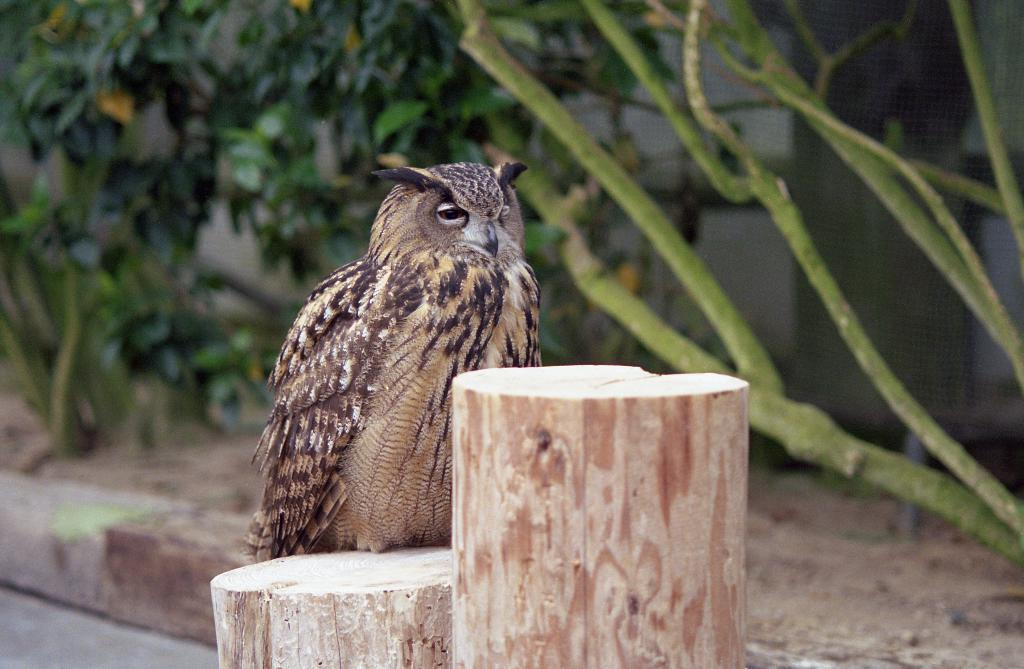What animal is the main subject of the image? There is an owl in the image. What is the owl sitting on? The owl is on a wooden object. What can be seen in the background of the image? There are plants and a mesh in the background of the image. What type of books can be seen in the image? There are no books present in the image; it features an owl on a wooden object with plants and a mesh in the background. What kind of worm is crawling on the owl's feathers in the image? There is no worm present in the image; it only features an owl on a wooden object with plants and a mesh in the background. 